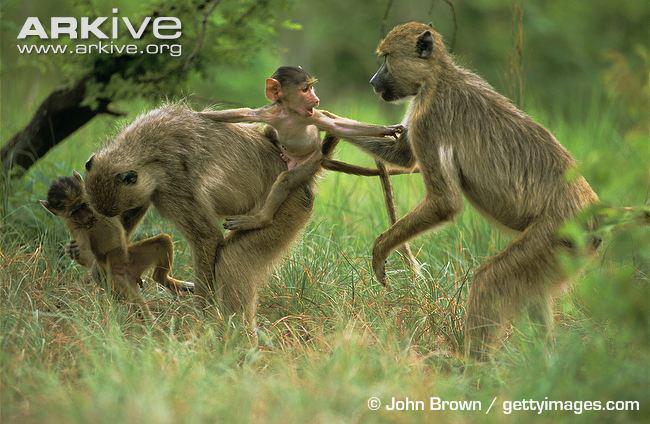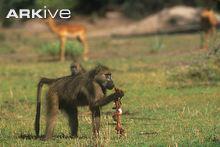The first image is the image on the left, the second image is the image on the right. Examine the images to the left and right. Is the description "A monkey in the image on the right happens to be holding something." accurate? Answer yes or no. Yes. The first image is the image on the left, the second image is the image on the right. Considering the images on both sides, is "there are no more than 4 baboons in the pair of images" valid? Answer yes or no. No. The first image is the image on the left, the second image is the image on the right. For the images displayed, is the sentence "in the right side the primate has something in its hands" factually correct? Answer yes or no. Yes. 